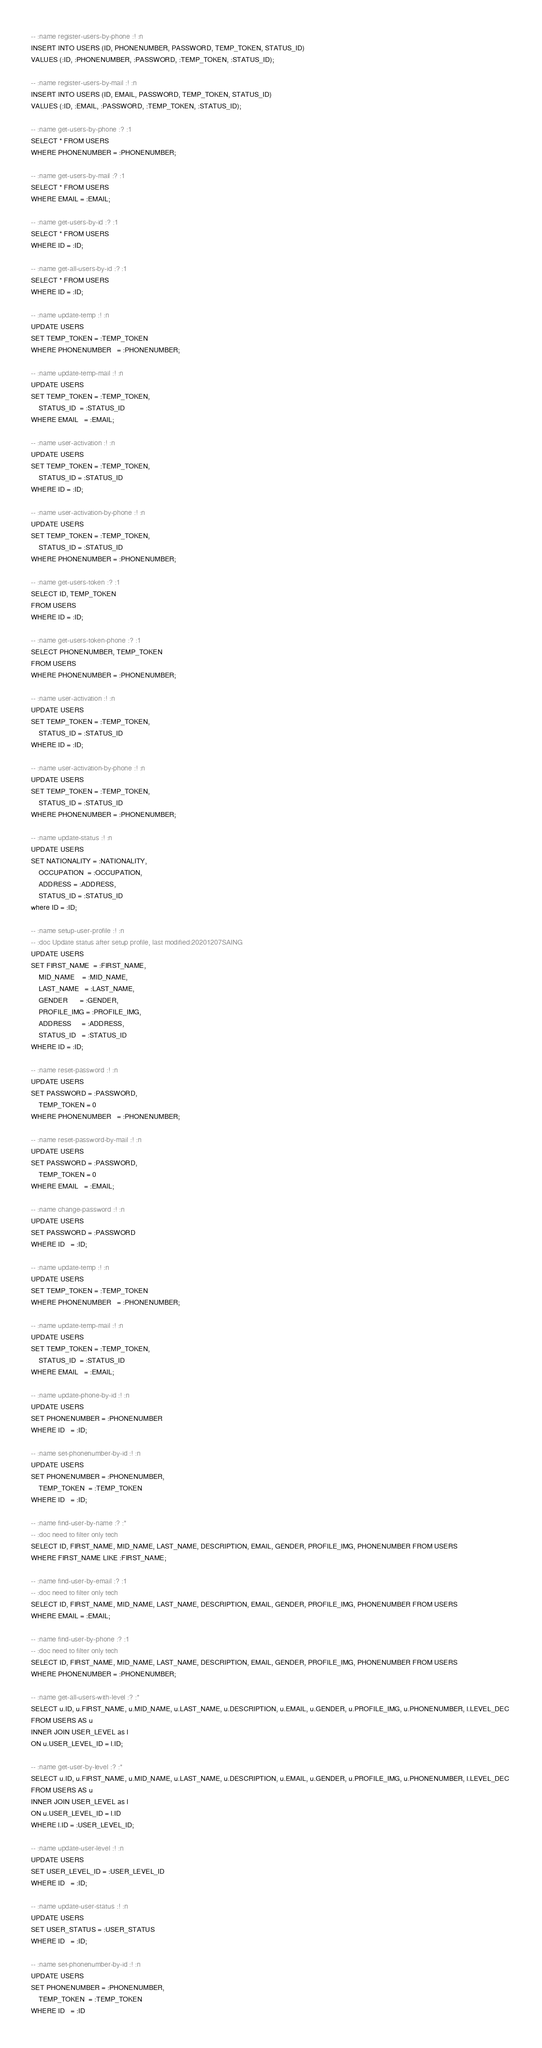Convert code to text. <code><loc_0><loc_0><loc_500><loc_500><_SQL_>-- :name register-users-by-phone :! :n 
INSERT INTO USERS (ID, PHONENUMBER, PASSWORD, TEMP_TOKEN, STATUS_ID)
VALUES (:ID, :PHONENUMBER, :PASSWORD, :TEMP_TOKEN, :STATUS_ID);

-- :name register-users-by-mail :! :n 
INSERT INTO USERS (ID, EMAIL, PASSWORD, TEMP_TOKEN, STATUS_ID)
VALUES (:ID, :EMAIL, :PASSWORD, :TEMP_TOKEN, :STATUS_ID);

-- :name get-users-by-phone :? :1
SELECT * FROM USERS 
WHERE PHONENUMBER = :PHONENUMBER;

-- :name get-users-by-mail :? :1
SELECT * FROM USERS 
WHERE EMAIL = :EMAIL;

-- :name get-users-by-id :? :1
SELECT * FROM USERS
WHERE ID = :ID;

-- :name get-all-users-by-id :? :1
SELECT * FROM USERS 
WHERE ID = :ID;

-- :name update-temp :! :n
UPDATE USERS
SET TEMP_TOKEN = :TEMP_TOKEN 
WHERE PHONENUMBER   = :PHONENUMBER;

-- :name update-temp-mail :! :n
UPDATE USERS
SET TEMP_TOKEN = :TEMP_TOKEN,
    STATUS_ID  = :STATUS_ID
WHERE EMAIL   = :EMAIL;

-- :name user-activation :! :n
UPDATE USERS
SET TEMP_TOKEN = :TEMP_TOKEN,
    STATUS_ID = :STATUS_ID
WHERE ID = :ID;

-- :name user-activation-by-phone :! :n
UPDATE USERS
SET TEMP_TOKEN = :TEMP_TOKEN,
    STATUS_ID = :STATUS_ID
WHERE PHONENUMBER = :PHONENUMBER;

-- :name get-users-token :? :1
SELECT ID, TEMP_TOKEN
FROM USERS 
WHERE ID = :ID;

-- :name get-users-token-phone :? :1
SELECT PHONENUMBER, TEMP_TOKEN
FROM USERS 
WHERE PHONENUMBER = :PHONENUMBER;

-- :name user-activation :! :n
UPDATE USERS
SET TEMP_TOKEN = :TEMP_TOKEN,
    STATUS_ID = :STATUS_ID
WHERE ID = :ID;

-- :name user-activation-by-phone :! :n
UPDATE USERS
SET TEMP_TOKEN = :TEMP_TOKEN,
    STATUS_ID = :STATUS_ID
WHERE PHONENUMBER = :PHONENUMBER;

-- :name update-status :! :n
UPDATE USERS
SET NATIONALITY = :NATIONALITY,
    OCCUPATION  = :OCCUPATION,
    ADDRESS = :ADDRESS,
    STATUS_ID = :STATUS_ID
where ID = :ID;

-- :name setup-user-profile :! :n
-- :doc Update status after setup profile, last modified:20201207SAING
UPDATE USERS
SET FIRST_NAME  = :FIRST_NAME,
    MID_NAME    = :MID_NAME,
    LAST_NAME   = :LAST_NAME,
    GENDER      = :GENDER,
    PROFILE_IMG = :PROFILE_IMG,
    ADDRESS     = :ADDRESS,
    STATUS_ID   = :STATUS_ID
WHERE ID = :ID;

-- :name reset-password :! :n
UPDATE USERS
SET PASSWORD = :PASSWORD, 
    TEMP_TOKEN = 0
WHERE PHONENUMBER   = :PHONENUMBER;

-- :name reset-password-by-mail :! :n
UPDATE USERS
SET PASSWORD = :PASSWORD, 
    TEMP_TOKEN = 0
WHERE EMAIL   = :EMAIL;

-- :name change-password :! :n
UPDATE USERS
SET PASSWORD = :PASSWORD
WHERE ID   = :ID;

-- :name update-temp :! :n
UPDATE USERS
SET TEMP_TOKEN = :TEMP_TOKEN 
WHERE PHONENUMBER   = :PHONENUMBER;

-- :name update-temp-mail :! :n
UPDATE USERS
SET TEMP_TOKEN = :TEMP_TOKEN,
    STATUS_ID  = :STATUS_ID
WHERE EMAIL   = :EMAIL;

-- :name update-phone-by-id :! :n
UPDATE USERS
SET PHONENUMBER = :PHONENUMBER 
WHERE ID   = :ID;

-- :name set-phonenumber-by-id :! :n
UPDATE USERS
SET PHONENUMBER = :PHONENUMBER,
    TEMP_TOKEN  = :TEMP_TOKEN
WHERE ID   = :ID;

-- :name find-user-by-name :? :*
-- :doc need to filter only tech
SELECT ID, FIRST_NAME, MID_NAME, LAST_NAME, DESCRIPTION, EMAIL, GENDER, PROFILE_IMG, PHONENUMBER FROM USERS
WHERE FIRST_NAME LIKE :FIRST_NAME; 

-- :name find-user-by-email :? :1
-- :doc need to filter only tech
SELECT ID, FIRST_NAME, MID_NAME, LAST_NAME, DESCRIPTION, EMAIL, GENDER, PROFILE_IMG, PHONENUMBER FROM USERS
WHERE EMAIL = :EMAIL; 

-- :name find-user-by-phone :? :1
-- :doc need to filter only tech
SELECT ID, FIRST_NAME, MID_NAME, LAST_NAME, DESCRIPTION, EMAIL, GENDER, PROFILE_IMG, PHONENUMBER FROM USERS
WHERE PHONENUMBER = :PHONENUMBER; 

-- :name get-all-users-with-level :? :*
SELECT u.ID, u.FIRST_NAME, u.MID_NAME, u.LAST_NAME, u.DESCRIPTION, u.EMAIL, u.GENDER, u.PROFILE_IMG, u.PHONENUMBER, l.LEVEL_DEC 
FROM USERS AS u
INNER JOIN USER_LEVEL as l
ON u.USER_LEVEL_ID = l.ID;

-- :name get-user-by-level :? :*
SELECT u.ID, u.FIRST_NAME, u.MID_NAME, u.LAST_NAME, u.DESCRIPTION, u.EMAIL, u.GENDER, u.PROFILE_IMG, u.PHONENUMBER, l.LEVEL_DEC 
FROM USERS AS u
INNER JOIN USER_LEVEL as l
ON u.USER_LEVEL_ID = l.ID
WHERE l.ID = :USER_LEVEL_ID;

-- :name update-user-level :! :n
UPDATE USERS
SET USER_LEVEL_ID = :USER_LEVEL_ID 
WHERE ID   = :ID;

-- :name update-user-status :! :n
UPDATE USERS
SET USER_STATUS = :USER_STATUS
WHERE ID   = :ID;

-- :name set-phonenumber-by-id :! :n
UPDATE USERS
SET PHONENUMBER = :PHONENUMBER,
    TEMP_TOKEN  = :TEMP_TOKEN
WHERE ID   = :ID</code> 